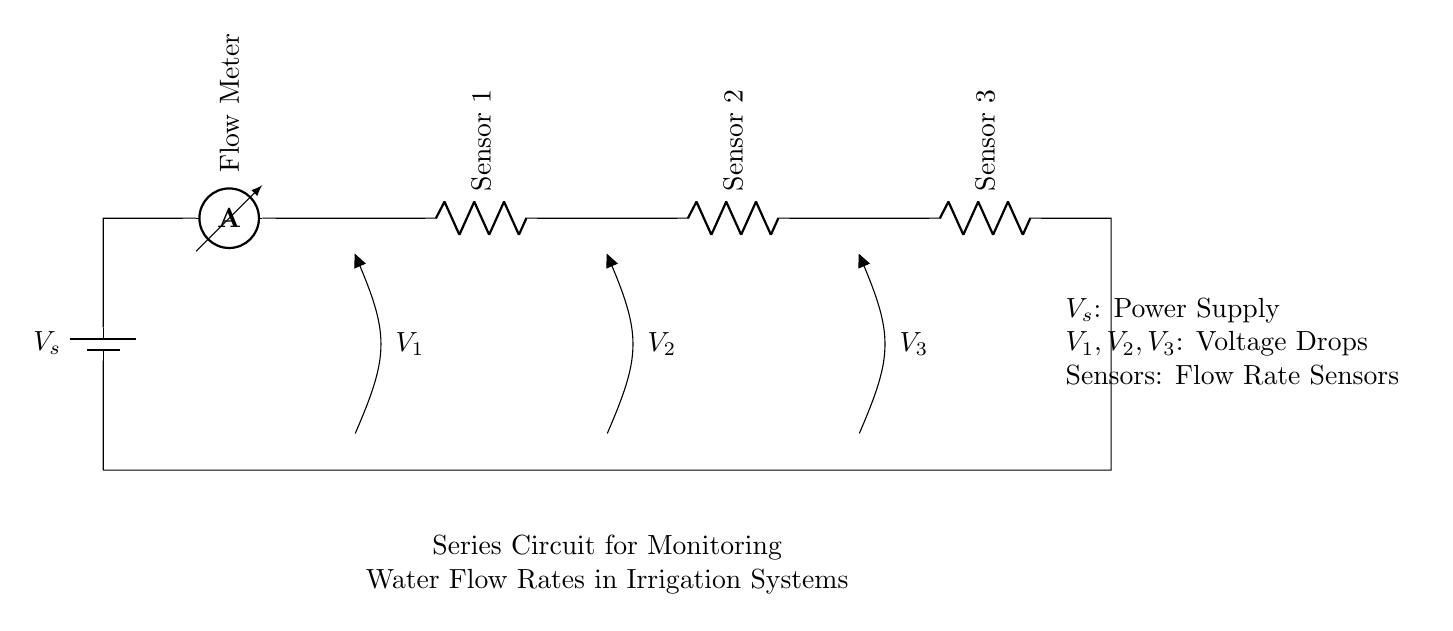What is the power supply voltage denoted as? The power supply voltage is denoted as V_s in the circuit. It indicates the source of electrical energy for the circuit components.
Answer: V_s What does the flow meter measure? The flow meter measures the flow rate of water in the irrigation system. Its position in the circuit signifies that it is the first component receiving current from the power supply, affecting the entire circuit's operation.
Answer: Flow Rate How many sensors are present in this circuit? There are three sensors (Sensor 1, Sensor 2, and Sensor 3) connected in series, indicating that each sensor contributes to the total resistance and affects the overall current flow.
Answer: Three What type of circuit is illustrated here? The circuit illustrated is a series circuit, where all components are connected end-to-end in a single path for current to flow. This configuration means that the same amount of current flows through all components.
Answer: Series What is the voltage drop across Sensor 1 labeled as? The voltage drop across Sensor 1 is labeled as V_1 in the circuit, indicating the potential difference across it while it is part of the overall series circuit setup.
Answer: V_1 If the total voltage is known, how would you calculate the voltage across each sensor? To calculate the voltage across each sensor, you would use Ohm's Law and the voltage divider principle; total voltage is divided proportionally among the resistive elements based on their resistances. This step requires knowledge of the total voltage and the individual resistances.
Answer: Ohm's Law What happens to current in a series circuit if one sensor fails? If one sensor fails (i.e., opens the circuit), current stops flowing through the entire circuit because in a series configuration, all components share a single path for current flow.
Answer: Stops 